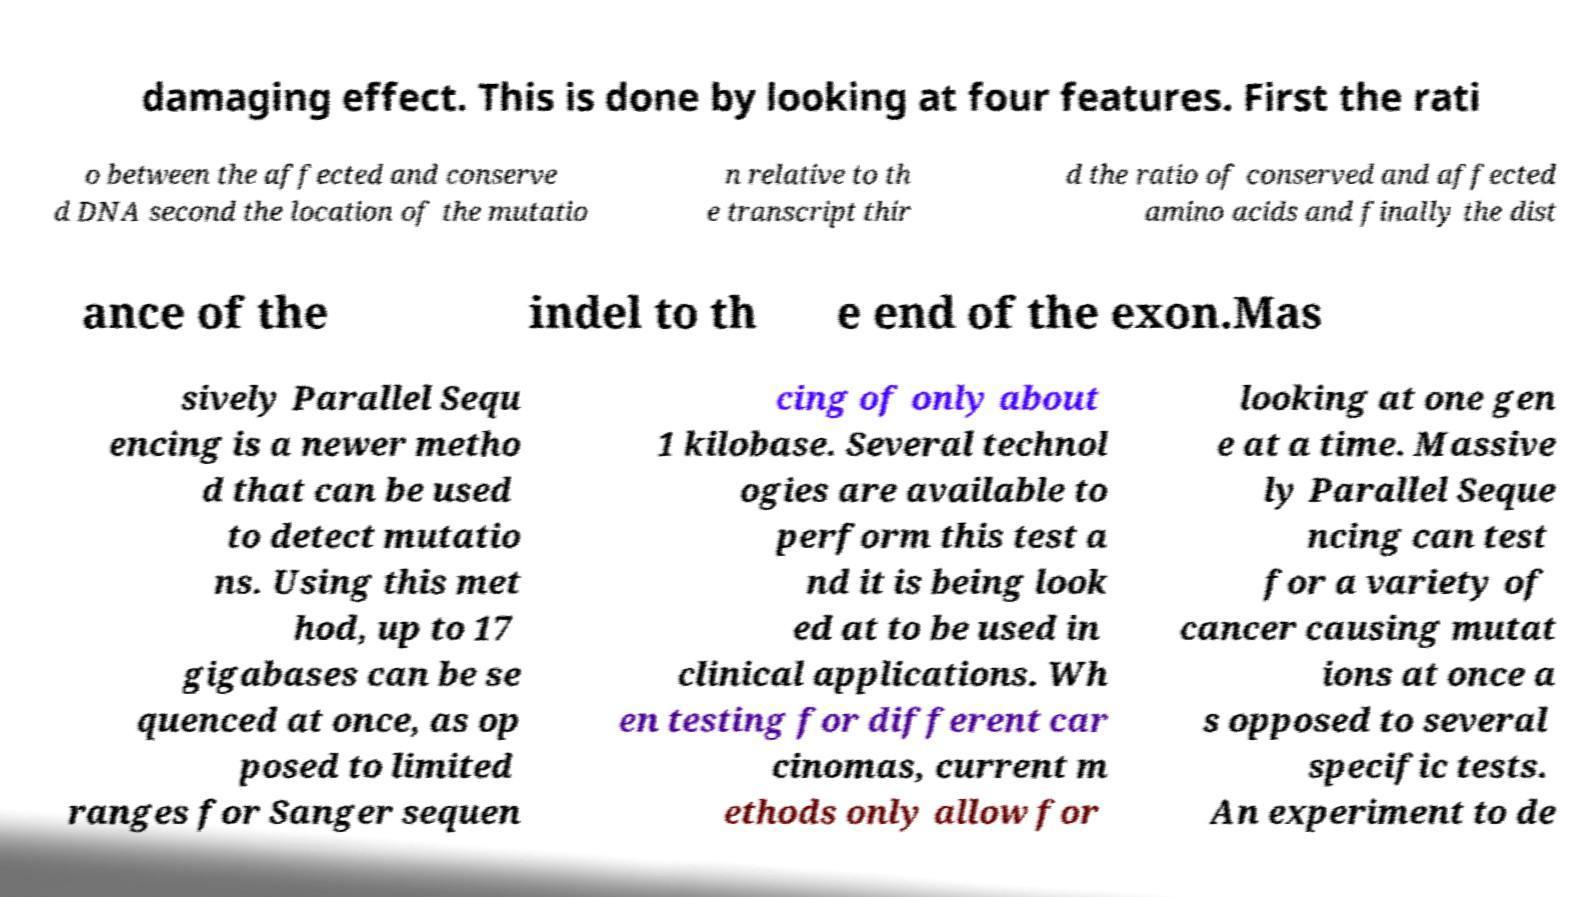Please read and relay the text visible in this image. What does it say? damaging effect. This is done by looking at four features. First the rati o between the affected and conserve d DNA second the location of the mutatio n relative to th e transcript thir d the ratio of conserved and affected amino acids and finally the dist ance of the indel to th e end of the exon.Mas sively Parallel Sequ encing is a newer metho d that can be used to detect mutatio ns. Using this met hod, up to 17 gigabases can be se quenced at once, as op posed to limited ranges for Sanger sequen cing of only about 1 kilobase. Several technol ogies are available to perform this test a nd it is being look ed at to be used in clinical applications. Wh en testing for different car cinomas, current m ethods only allow for looking at one gen e at a time. Massive ly Parallel Seque ncing can test for a variety of cancer causing mutat ions at once a s opposed to several specific tests. An experiment to de 